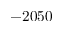Convert formula to latex. <formula><loc_0><loc_0><loc_500><loc_500>- 2 0 5 0</formula> 